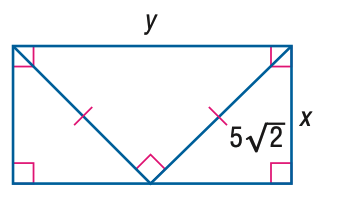Answer the mathemtical geometry problem and directly provide the correct option letter.
Question: Find y.
Choices: A: 5 B: 5 \sqrt { 2 } C: 10 D: 10 \sqrt { 2 } C 